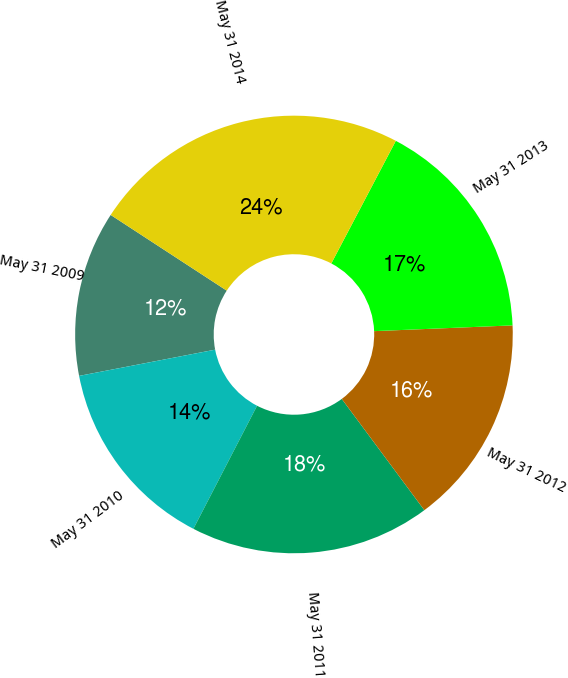<chart> <loc_0><loc_0><loc_500><loc_500><pie_chart><fcel>May 31 2009<fcel>May 31 2010<fcel>May 31 2011<fcel>May 31 2012<fcel>May 31 2013<fcel>May 31 2014<nl><fcel>12.23%<fcel>14.37%<fcel>17.76%<fcel>15.5%<fcel>16.63%<fcel>23.51%<nl></chart> 